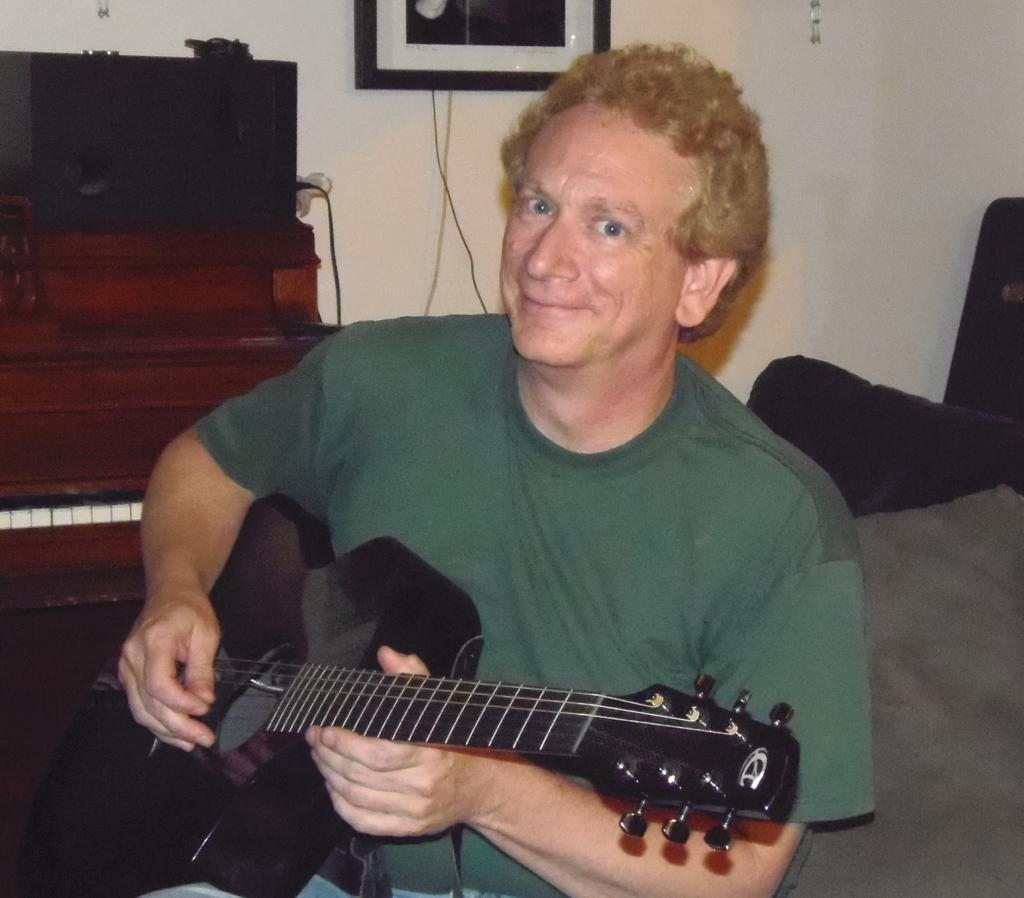What is the person in the image doing? The person is sitting and playing a guitar. What is the person's facial expression in the image? The person is smiling. What can be seen in the background of the image? There is a wall, a frame, an electrical device, and a piano keyboard in the background. Can you tell me how the person is using a match in the image? There is no match present in the image. What type of swimming technique is the person using while playing the guitar? The person is sitting and playing the guitar, and there is no swimming activity depicted in the image. 